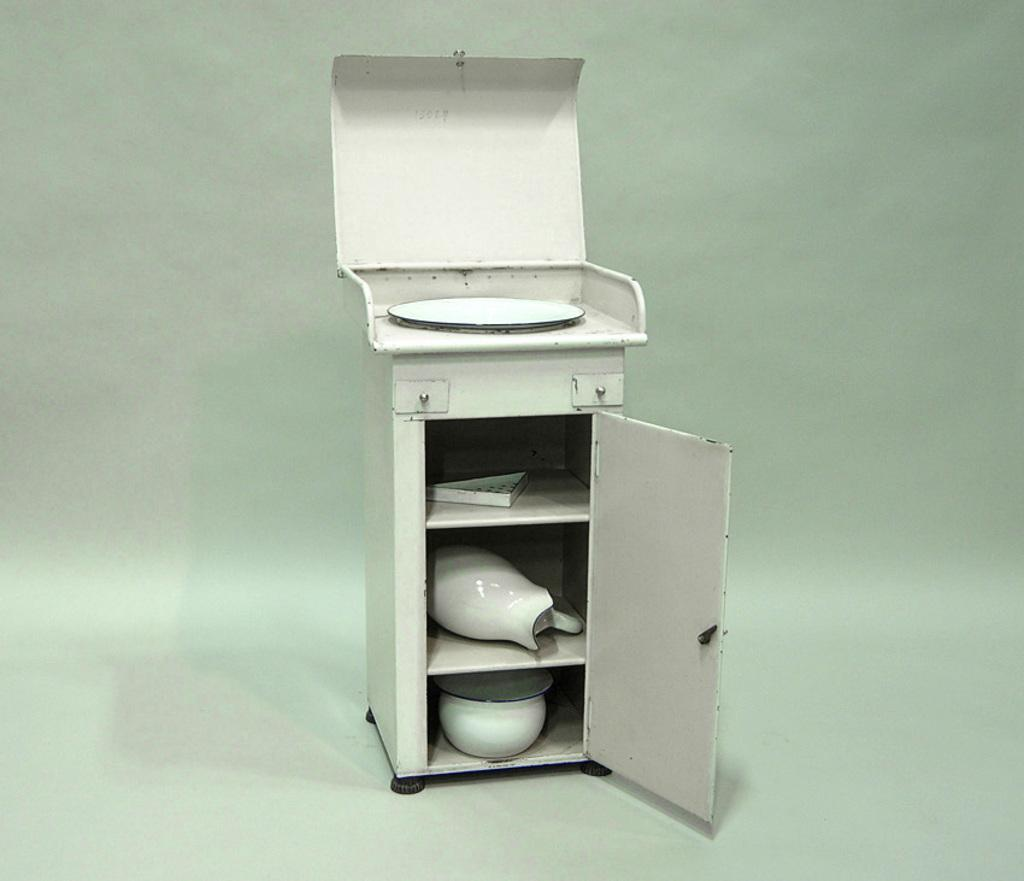What is the main object in the center of the image? There is a cupboard in the center of the image. What can be found inside the cupboard? There is a pot and a vessel in the cupboard. Is there anything else on the cupboard besides the pot and vessel? Yes, there is a plate on the cupboard. What type of ink is being used to write on the plate in the image? There is no ink or writing present on the plate in the image. What type of beef is being stored in the cupboard? There is no beef present in the image; it only contains a pot, a vessel, and a plate. 